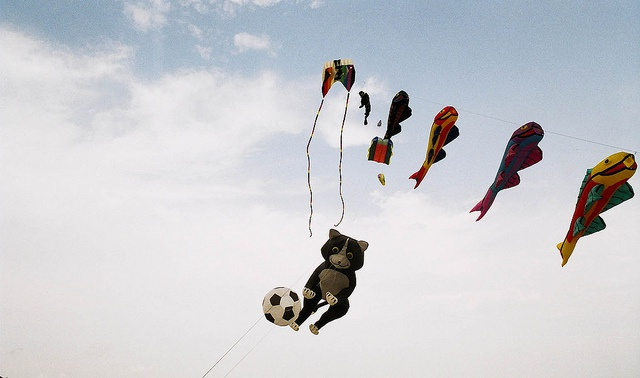Describe the objects in this image and their specific colors. I can see kite in darkgray, black, gray, white, and tan tones, teddy bear in darkgray, black, and gray tones, kite in darkgray, black, maroon, and olive tones, kite in darkgray, black, maroon, blue, and gray tones, and kite in darkgray, black, maroon, and olive tones in this image. 